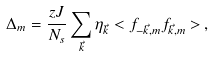<formula> <loc_0><loc_0><loc_500><loc_500>\Delta _ { m } = \frac { z J } { N _ { s } } \sum _ { \vec { k } } \eta _ { \vec { k } } < f _ { - \vec { k } , m } f _ { \vec { k } , m } > \, ,</formula> 